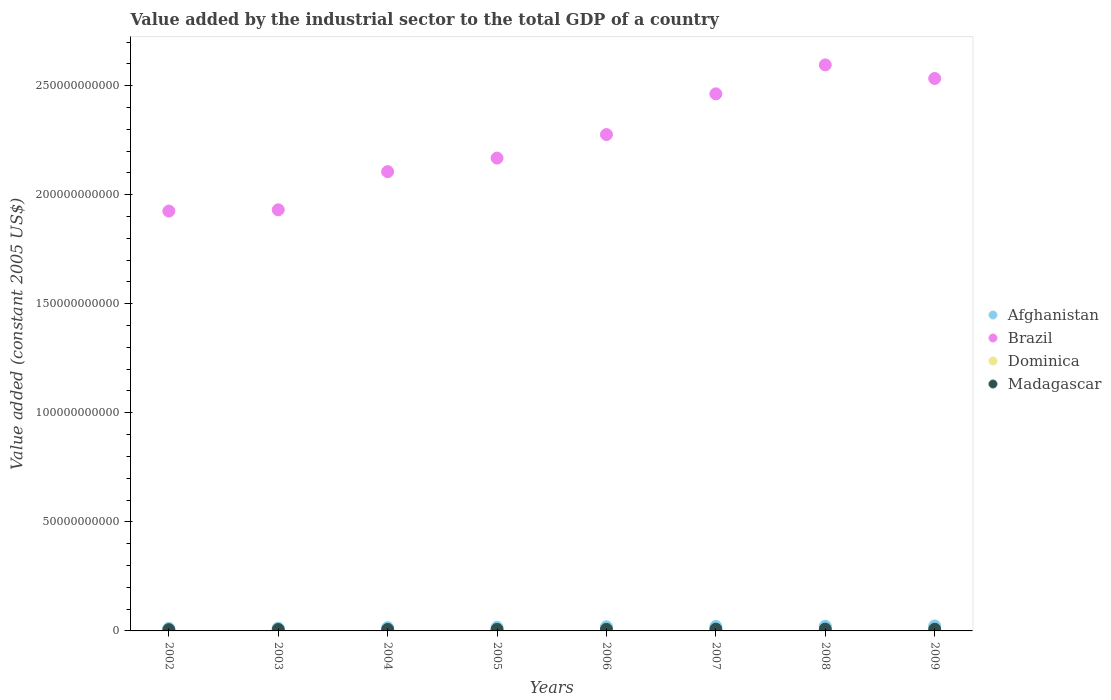What is the value added by the industrial sector in Afghanistan in 2006?
Give a very brief answer. 1.89e+09. Across all years, what is the maximum value added by the industrial sector in Brazil?
Make the answer very short. 2.60e+11. Across all years, what is the minimum value added by the industrial sector in Madagascar?
Offer a very short reply. 5.74e+08. What is the total value added by the industrial sector in Afghanistan in the graph?
Make the answer very short. 1.39e+1. What is the difference between the value added by the industrial sector in Afghanistan in 2005 and that in 2006?
Offer a terse response. -2.28e+08. What is the difference between the value added by the industrial sector in Madagascar in 2003 and the value added by the industrial sector in Afghanistan in 2005?
Make the answer very short. -1.01e+09. What is the average value added by the industrial sector in Brazil per year?
Your answer should be very brief. 2.25e+11. In the year 2006, what is the difference between the value added by the industrial sector in Dominica and value added by the industrial sector in Afghanistan?
Make the answer very short. -1.84e+09. What is the ratio of the value added by the industrial sector in Afghanistan in 2003 to that in 2006?
Provide a short and direct response. 0.66. What is the difference between the highest and the second highest value added by the industrial sector in Afghanistan?
Make the answer very short. 1.32e+08. What is the difference between the highest and the lowest value added by the industrial sector in Dominica?
Your answer should be very brief. 2.07e+07. In how many years, is the value added by the industrial sector in Madagascar greater than the average value added by the industrial sector in Madagascar taken over all years?
Ensure brevity in your answer.  4. Is the sum of the value added by the industrial sector in Afghanistan in 2002 and 2003 greater than the maximum value added by the industrial sector in Brazil across all years?
Give a very brief answer. No. Is it the case that in every year, the sum of the value added by the industrial sector in Brazil and value added by the industrial sector in Afghanistan  is greater than the sum of value added by the industrial sector in Madagascar and value added by the industrial sector in Dominica?
Provide a short and direct response. Yes. Is the value added by the industrial sector in Dominica strictly greater than the value added by the industrial sector in Afghanistan over the years?
Provide a succinct answer. No. Is the value added by the industrial sector in Afghanistan strictly less than the value added by the industrial sector in Dominica over the years?
Make the answer very short. No. How many dotlines are there?
Offer a terse response. 4. How many years are there in the graph?
Provide a short and direct response. 8. What is the difference between two consecutive major ticks on the Y-axis?
Make the answer very short. 5.00e+1. Are the values on the major ticks of Y-axis written in scientific E-notation?
Offer a terse response. No. Does the graph contain any zero values?
Your response must be concise. No. How are the legend labels stacked?
Your response must be concise. Vertical. What is the title of the graph?
Offer a very short reply. Value added by the industrial sector to the total GDP of a country. What is the label or title of the Y-axis?
Your answer should be very brief. Value added (constant 2005 US$). What is the Value added (constant 2005 US$) in Afghanistan in 2002?
Offer a terse response. 1.14e+09. What is the Value added (constant 2005 US$) in Brazil in 2002?
Your answer should be compact. 1.92e+11. What is the Value added (constant 2005 US$) of Dominica in 2002?
Offer a very short reply. 3.76e+07. What is the Value added (constant 2005 US$) of Madagascar in 2002?
Your answer should be very brief. 5.74e+08. What is the Value added (constant 2005 US$) of Afghanistan in 2003?
Keep it short and to the point. 1.25e+09. What is the Value added (constant 2005 US$) in Brazil in 2003?
Provide a succinct answer. 1.93e+11. What is the Value added (constant 2005 US$) of Dominica in 2003?
Offer a terse response. 4.21e+07. What is the Value added (constant 2005 US$) in Madagascar in 2003?
Provide a succinct answer. 6.58e+08. What is the Value added (constant 2005 US$) of Afghanistan in 2004?
Your response must be concise. 1.47e+09. What is the Value added (constant 2005 US$) in Brazil in 2004?
Keep it short and to the point. 2.11e+11. What is the Value added (constant 2005 US$) of Dominica in 2004?
Your answer should be compact. 4.60e+07. What is the Value added (constant 2005 US$) of Madagascar in 2004?
Keep it short and to the point. 7.01e+08. What is the Value added (constant 2005 US$) of Afghanistan in 2005?
Ensure brevity in your answer.  1.66e+09. What is the Value added (constant 2005 US$) of Brazil in 2005?
Give a very brief answer. 2.17e+11. What is the Value added (constant 2005 US$) of Dominica in 2005?
Keep it short and to the point. 4.74e+07. What is the Value added (constant 2005 US$) of Madagascar in 2005?
Provide a succinct answer. 7.21e+08. What is the Value added (constant 2005 US$) in Afghanistan in 2006?
Provide a succinct answer. 1.89e+09. What is the Value added (constant 2005 US$) of Brazil in 2006?
Offer a very short reply. 2.28e+11. What is the Value added (constant 2005 US$) in Dominica in 2006?
Give a very brief answer. 4.98e+07. What is the Value added (constant 2005 US$) in Madagascar in 2006?
Make the answer very short. 7.47e+08. What is the Value added (constant 2005 US$) in Afghanistan in 2007?
Provide a short and direct response. 2.04e+09. What is the Value added (constant 2005 US$) in Brazil in 2007?
Provide a succinct answer. 2.46e+11. What is the Value added (constant 2005 US$) of Dominica in 2007?
Offer a very short reply. 5.39e+07. What is the Value added (constant 2005 US$) of Madagascar in 2007?
Provide a short and direct response. 8.20e+08. What is the Value added (constant 2005 US$) of Afghanistan in 2008?
Your response must be concise. 2.15e+09. What is the Value added (constant 2005 US$) in Brazil in 2008?
Your answer should be compact. 2.60e+11. What is the Value added (constant 2005 US$) of Dominica in 2008?
Your answer should be very brief. 5.82e+07. What is the Value added (constant 2005 US$) in Madagascar in 2008?
Make the answer very short. 8.50e+08. What is the Value added (constant 2005 US$) in Afghanistan in 2009?
Give a very brief answer. 2.29e+09. What is the Value added (constant 2005 US$) in Brazil in 2009?
Make the answer very short. 2.53e+11. What is the Value added (constant 2005 US$) of Dominica in 2009?
Ensure brevity in your answer.  5.35e+07. What is the Value added (constant 2005 US$) in Madagascar in 2009?
Your answer should be very brief. 7.83e+08. Across all years, what is the maximum Value added (constant 2005 US$) of Afghanistan?
Give a very brief answer. 2.29e+09. Across all years, what is the maximum Value added (constant 2005 US$) in Brazil?
Your response must be concise. 2.60e+11. Across all years, what is the maximum Value added (constant 2005 US$) of Dominica?
Your answer should be compact. 5.82e+07. Across all years, what is the maximum Value added (constant 2005 US$) of Madagascar?
Ensure brevity in your answer.  8.50e+08. Across all years, what is the minimum Value added (constant 2005 US$) of Afghanistan?
Offer a very short reply. 1.14e+09. Across all years, what is the minimum Value added (constant 2005 US$) of Brazil?
Give a very brief answer. 1.92e+11. Across all years, what is the minimum Value added (constant 2005 US$) of Dominica?
Provide a short and direct response. 3.76e+07. Across all years, what is the minimum Value added (constant 2005 US$) of Madagascar?
Ensure brevity in your answer.  5.74e+08. What is the total Value added (constant 2005 US$) of Afghanistan in the graph?
Your answer should be compact. 1.39e+1. What is the total Value added (constant 2005 US$) in Brazil in the graph?
Offer a very short reply. 1.80e+12. What is the total Value added (constant 2005 US$) in Dominica in the graph?
Make the answer very short. 3.89e+08. What is the total Value added (constant 2005 US$) in Madagascar in the graph?
Give a very brief answer. 5.85e+09. What is the difference between the Value added (constant 2005 US$) of Afghanistan in 2002 and that in 2003?
Ensure brevity in your answer.  -1.17e+08. What is the difference between the Value added (constant 2005 US$) in Brazil in 2002 and that in 2003?
Your answer should be very brief. -5.84e+08. What is the difference between the Value added (constant 2005 US$) of Dominica in 2002 and that in 2003?
Provide a succinct answer. -4.49e+06. What is the difference between the Value added (constant 2005 US$) of Madagascar in 2002 and that in 2003?
Offer a terse response. -8.32e+07. What is the difference between the Value added (constant 2005 US$) in Afghanistan in 2002 and that in 2004?
Give a very brief answer. -3.36e+08. What is the difference between the Value added (constant 2005 US$) in Brazil in 2002 and that in 2004?
Offer a very short reply. -1.81e+1. What is the difference between the Value added (constant 2005 US$) of Dominica in 2002 and that in 2004?
Provide a short and direct response. -8.46e+06. What is the difference between the Value added (constant 2005 US$) of Madagascar in 2002 and that in 2004?
Keep it short and to the point. -1.26e+08. What is the difference between the Value added (constant 2005 US$) in Afghanistan in 2002 and that in 2005?
Keep it short and to the point. -5.27e+08. What is the difference between the Value added (constant 2005 US$) in Brazil in 2002 and that in 2005?
Make the answer very short. -2.43e+1. What is the difference between the Value added (constant 2005 US$) in Dominica in 2002 and that in 2005?
Provide a succinct answer. -9.82e+06. What is the difference between the Value added (constant 2005 US$) in Madagascar in 2002 and that in 2005?
Offer a terse response. -1.47e+08. What is the difference between the Value added (constant 2005 US$) of Afghanistan in 2002 and that in 2006?
Offer a very short reply. -7.55e+08. What is the difference between the Value added (constant 2005 US$) of Brazil in 2002 and that in 2006?
Offer a very short reply. -3.51e+1. What is the difference between the Value added (constant 2005 US$) of Dominica in 2002 and that in 2006?
Offer a terse response. -1.22e+07. What is the difference between the Value added (constant 2005 US$) of Madagascar in 2002 and that in 2006?
Offer a very short reply. -1.73e+08. What is the difference between the Value added (constant 2005 US$) in Afghanistan in 2002 and that in 2007?
Make the answer very short. -8.99e+08. What is the difference between the Value added (constant 2005 US$) of Brazil in 2002 and that in 2007?
Make the answer very short. -5.37e+1. What is the difference between the Value added (constant 2005 US$) in Dominica in 2002 and that in 2007?
Make the answer very short. -1.63e+07. What is the difference between the Value added (constant 2005 US$) of Madagascar in 2002 and that in 2007?
Ensure brevity in your answer.  -2.46e+08. What is the difference between the Value added (constant 2005 US$) in Afghanistan in 2002 and that in 2008?
Offer a very short reply. -1.02e+09. What is the difference between the Value added (constant 2005 US$) of Brazil in 2002 and that in 2008?
Offer a terse response. -6.70e+1. What is the difference between the Value added (constant 2005 US$) in Dominica in 2002 and that in 2008?
Your answer should be compact. -2.07e+07. What is the difference between the Value added (constant 2005 US$) in Madagascar in 2002 and that in 2008?
Your answer should be compact. -2.75e+08. What is the difference between the Value added (constant 2005 US$) in Afghanistan in 2002 and that in 2009?
Provide a short and direct response. -1.15e+09. What is the difference between the Value added (constant 2005 US$) in Brazil in 2002 and that in 2009?
Provide a succinct answer. -6.08e+1. What is the difference between the Value added (constant 2005 US$) in Dominica in 2002 and that in 2009?
Your response must be concise. -1.59e+07. What is the difference between the Value added (constant 2005 US$) in Madagascar in 2002 and that in 2009?
Your answer should be very brief. -2.09e+08. What is the difference between the Value added (constant 2005 US$) in Afghanistan in 2003 and that in 2004?
Offer a terse response. -2.19e+08. What is the difference between the Value added (constant 2005 US$) in Brazil in 2003 and that in 2004?
Ensure brevity in your answer.  -1.75e+1. What is the difference between the Value added (constant 2005 US$) in Dominica in 2003 and that in 2004?
Offer a very short reply. -3.97e+06. What is the difference between the Value added (constant 2005 US$) in Madagascar in 2003 and that in 2004?
Ensure brevity in your answer.  -4.31e+07. What is the difference between the Value added (constant 2005 US$) of Afghanistan in 2003 and that in 2005?
Provide a short and direct response. -4.11e+08. What is the difference between the Value added (constant 2005 US$) in Brazil in 2003 and that in 2005?
Ensure brevity in your answer.  -2.37e+1. What is the difference between the Value added (constant 2005 US$) of Dominica in 2003 and that in 2005?
Make the answer very short. -5.34e+06. What is the difference between the Value added (constant 2005 US$) in Madagascar in 2003 and that in 2005?
Your response must be concise. -6.38e+07. What is the difference between the Value added (constant 2005 US$) of Afghanistan in 2003 and that in 2006?
Provide a succinct answer. -6.38e+08. What is the difference between the Value added (constant 2005 US$) of Brazil in 2003 and that in 2006?
Your answer should be compact. -3.45e+1. What is the difference between the Value added (constant 2005 US$) in Dominica in 2003 and that in 2006?
Make the answer very short. -7.73e+06. What is the difference between the Value added (constant 2005 US$) in Madagascar in 2003 and that in 2006?
Your response must be concise. -8.93e+07. What is the difference between the Value added (constant 2005 US$) of Afghanistan in 2003 and that in 2007?
Your answer should be compact. -7.83e+08. What is the difference between the Value added (constant 2005 US$) in Brazil in 2003 and that in 2007?
Give a very brief answer. -5.32e+1. What is the difference between the Value added (constant 2005 US$) in Dominica in 2003 and that in 2007?
Your answer should be very brief. -1.18e+07. What is the difference between the Value added (constant 2005 US$) of Madagascar in 2003 and that in 2007?
Provide a succinct answer. -1.63e+08. What is the difference between the Value added (constant 2005 US$) of Afghanistan in 2003 and that in 2008?
Give a very brief answer. -8.99e+08. What is the difference between the Value added (constant 2005 US$) in Brazil in 2003 and that in 2008?
Your response must be concise. -6.64e+1. What is the difference between the Value added (constant 2005 US$) of Dominica in 2003 and that in 2008?
Provide a succinct answer. -1.62e+07. What is the difference between the Value added (constant 2005 US$) of Madagascar in 2003 and that in 2008?
Provide a succinct answer. -1.92e+08. What is the difference between the Value added (constant 2005 US$) of Afghanistan in 2003 and that in 2009?
Provide a succinct answer. -1.03e+09. What is the difference between the Value added (constant 2005 US$) of Brazil in 2003 and that in 2009?
Provide a succinct answer. -6.02e+1. What is the difference between the Value added (constant 2005 US$) in Dominica in 2003 and that in 2009?
Offer a terse response. -1.15e+07. What is the difference between the Value added (constant 2005 US$) in Madagascar in 2003 and that in 2009?
Your response must be concise. -1.26e+08. What is the difference between the Value added (constant 2005 US$) of Afghanistan in 2004 and that in 2005?
Ensure brevity in your answer.  -1.91e+08. What is the difference between the Value added (constant 2005 US$) in Brazil in 2004 and that in 2005?
Your answer should be compact. -6.22e+09. What is the difference between the Value added (constant 2005 US$) in Dominica in 2004 and that in 2005?
Your answer should be very brief. -1.36e+06. What is the difference between the Value added (constant 2005 US$) in Madagascar in 2004 and that in 2005?
Your answer should be compact. -2.08e+07. What is the difference between the Value added (constant 2005 US$) in Afghanistan in 2004 and that in 2006?
Your answer should be compact. -4.19e+08. What is the difference between the Value added (constant 2005 US$) of Brazil in 2004 and that in 2006?
Your response must be concise. -1.70e+1. What is the difference between the Value added (constant 2005 US$) in Dominica in 2004 and that in 2006?
Offer a very short reply. -3.76e+06. What is the difference between the Value added (constant 2005 US$) of Madagascar in 2004 and that in 2006?
Provide a short and direct response. -4.63e+07. What is the difference between the Value added (constant 2005 US$) in Afghanistan in 2004 and that in 2007?
Your answer should be very brief. -5.63e+08. What is the difference between the Value added (constant 2005 US$) of Brazil in 2004 and that in 2007?
Offer a very short reply. -3.57e+1. What is the difference between the Value added (constant 2005 US$) in Dominica in 2004 and that in 2007?
Your answer should be very brief. -7.86e+06. What is the difference between the Value added (constant 2005 US$) of Madagascar in 2004 and that in 2007?
Your answer should be very brief. -1.20e+08. What is the difference between the Value added (constant 2005 US$) of Afghanistan in 2004 and that in 2008?
Offer a very short reply. -6.80e+08. What is the difference between the Value added (constant 2005 US$) of Brazil in 2004 and that in 2008?
Your answer should be very brief. -4.90e+1. What is the difference between the Value added (constant 2005 US$) in Dominica in 2004 and that in 2008?
Ensure brevity in your answer.  -1.22e+07. What is the difference between the Value added (constant 2005 US$) of Madagascar in 2004 and that in 2008?
Give a very brief answer. -1.49e+08. What is the difference between the Value added (constant 2005 US$) of Afghanistan in 2004 and that in 2009?
Your answer should be compact. -8.12e+08. What is the difference between the Value added (constant 2005 US$) in Brazil in 2004 and that in 2009?
Make the answer very short. -4.27e+1. What is the difference between the Value added (constant 2005 US$) of Dominica in 2004 and that in 2009?
Ensure brevity in your answer.  -7.49e+06. What is the difference between the Value added (constant 2005 US$) of Madagascar in 2004 and that in 2009?
Provide a succinct answer. -8.26e+07. What is the difference between the Value added (constant 2005 US$) of Afghanistan in 2005 and that in 2006?
Ensure brevity in your answer.  -2.28e+08. What is the difference between the Value added (constant 2005 US$) in Brazil in 2005 and that in 2006?
Provide a short and direct response. -1.08e+1. What is the difference between the Value added (constant 2005 US$) in Dominica in 2005 and that in 2006?
Make the answer very short. -2.40e+06. What is the difference between the Value added (constant 2005 US$) of Madagascar in 2005 and that in 2006?
Make the answer very short. -2.55e+07. What is the difference between the Value added (constant 2005 US$) of Afghanistan in 2005 and that in 2007?
Make the answer very short. -3.72e+08. What is the difference between the Value added (constant 2005 US$) in Brazil in 2005 and that in 2007?
Your answer should be very brief. -2.95e+1. What is the difference between the Value added (constant 2005 US$) in Dominica in 2005 and that in 2007?
Provide a succinct answer. -6.49e+06. What is the difference between the Value added (constant 2005 US$) in Madagascar in 2005 and that in 2007?
Keep it short and to the point. -9.88e+07. What is the difference between the Value added (constant 2005 US$) of Afghanistan in 2005 and that in 2008?
Provide a short and direct response. -4.89e+08. What is the difference between the Value added (constant 2005 US$) in Brazil in 2005 and that in 2008?
Provide a short and direct response. -4.27e+1. What is the difference between the Value added (constant 2005 US$) in Dominica in 2005 and that in 2008?
Provide a succinct answer. -1.08e+07. What is the difference between the Value added (constant 2005 US$) in Madagascar in 2005 and that in 2008?
Give a very brief answer. -1.28e+08. What is the difference between the Value added (constant 2005 US$) in Afghanistan in 2005 and that in 2009?
Keep it short and to the point. -6.20e+08. What is the difference between the Value added (constant 2005 US$) in Brazil in 2005 and that in 2009?
Provide a short and direct response. -3.65e+1. What is the difference between the Value added (constant 2005 US$) of Dominica in 2005 and that in 2009?
Keep it short and to the point. -6.12e+06. What is the difference between the Value added (constant 2005 US$) in Madagascar in 2005 and that in 2009?
Offer a terse response. -6.19e+07. What is the difference between the Value added (constant 2005 US$) in Afghanistan in 2006 and that in 2007?
Offer a terse response. -1.44e+08. What is the difference between the Value added (constant 2005 US$) in Brazil in 2006 and that in 2007?
Ensure brevity in your answer.  -1.87e+1. What is the difference between the Value added (constant 2005 US$) in Dominica in 2006 and that in 2007?
Your answer should be very brief. -4.09e+06. What is the difference between the Value added (constant 2005 US$) in Madagascar in 2006 and that in 2007?
Keep it short and to the point. -7.33e+07. What is the difference between the Value added (constant 2005 US$) in Afghanistan in 2006 and that in 2008?
Offer a very short reply. -2.61e+08. What is the difference between the Value added (constant 2005 US$) in Brazil in 2006 and that in 2008?
Offer a terse response. -3.19e+1. What is the difference between the Value added (constant 2005 US$) in Dominica in 2006 and that in 2008?
Ensure brevity in your answer.  -8.44e+06. What is the difference between the Value added (constant 2005 US$) in Madagascar in 2006 and that in 2008?
Give a very brief answer. -1.03e+08. What is the difference between the Value added (constant 2005 US$) of Afghanistan in 2006 and that in 2009?
Your answer should be very brief. -3.93e+08. What is the difference between the Value added (constant 2005 US$) in Brazil in 2006 and that in 2009?
Provide a short and direct response. -2.57e+1. What is the difference between the Value added (constant 2005 US$) of Dominica in 2006 and that in 2009?
Your answer should be compact. -3.72e+06. What is the difference between the Value added (constant 2005 US$) of Madagascar in 2006 and that in 2009?
Provide a succinct answer. -3.64e+07. What is the difference between the Value added (constant 2005 US$) of Afghanistan in 2007 and that in 2008?
Offer a terse response. -1.17e+08. What is the difference between the Value added (constant 2005 US$) of Brazil in 2007 and that in 2008?
Provide a short and direct response. -1.33e+1. What is the difference between the Value added (constant 2005 US$) of Dominica in 2007 and that in 2008?
Your answer should be compact. -4.34e+06. What is the difference between the Value added (constant 2005 US$) of Madagascar in 2007 and that in 2008?
Your answer should be very brief. -2.93e+07. What is the difference between the Value added (constant 2005 US$) in Afghanistan in 2007 and that in 2009?
Your answer should be very brief. -2.48e+08. What is the difference between the Value added (constant 2005 US$) in Brazil in 2007 and that in 2009?
Provide a short and direct response. -7.04e+09. What is the difference between the Value added (constant 2005 US$) of Dominica in 2007 and that in 2009?
Your answer should be very brief. 3.71e+05. What is the difference between the Value added (constant 2005 US$) in Madagascar in 2007 and that in 2009?
Give a very brief answer. 3.70e+07. What is the difference between the Value added (constant 2005 US$) in Afghanistan in 2008 and that in 2009?
Make the answer very short. -1.32e+08. What is the difference between the Value added (constant 2005 US$) in Brazil in 2008 and that in 2009?
Offer a terse response. 6.24e+09. What is the difference between the Value added (constant 2005 US$) in Dominica in 2008 and that in 2009?
Provide a short and direct response. 4.72e+06. What is the difference between the Value added (constant 2005 US$) in Madagascar in 2008 and that in 2009?
Offer a terse response. 6.63e+07. What is the difference between the Value added (constant 2005 US$) of Afghanistan in 2002 and the Value added (constant 2005 US$) of Brazil in 2003?
Your answer should be very brief. -1.92e+11. What is the difference between the Value added (constant 2005 US$) of Afghanistan in 2002 and the Value added (constant 2005 US$) of Dominica in 2003?
Ensure brevity in your answer.  1.10e+09. What is the difference between the Value added (constant 2005 US$) in Afghanistan in 2002 and the Value added (constant 2005 US$) in Madagascar in 2003?
Provide a short and direct response. 4.80e+08. What is the difference between the Value added (constant 2005 US$) in Brazil in 2002 and the Value added (constant 2005 US$) in Dominica in 2003?
Your answer should be compact. 1.92e+11. What is the difference between the Value added (constant 2005 US$) in Brazil in 2002 and the Value added (constant 2005 US$) in Madagascar in 2003?
Provide a succinct answer. 1.92e+11. What is the difference between the Value added (constant 2005 US$) in Dominica in 2002 and the Value added (constant 2005 US$) in Madagascar in 2003?
Offer a terse response. -6.20e+08. What is the difference between the Value added (constant 2005 US$) in Afghanistan in 2002 and the Value added (constant 2005 US$) in Brazil in 2004?
Offer a very short reply. -2.09e+11. What is the difference between the Value added (constant 2005 US$) of Afghanistan in 2002 and the Value added (constant 2005 US$) of Dominica in 2004?
Give a very brief answer. 1.09e+09. What is the difference between the Value added (constant 2005 US$) in Afghanistan in 2002 and the Value added (constant 2005 US$) in Madagascar in 2004?
Your answer should be very brief. 4.37e+08. What is the difference between the Value added (constant 2005 US$) of Brazil in 2002 and the Value added (constant 2005 US$) of Dominica in 2004?
Your response must be concise. 1.92e+11. What is the difference between the Value added (constant 2005 US$) in Brazil in 2002 and the Value added (constant 2005 US$) in Madagascar in 2004?
Ensure brevity in your answer.  1.92e+11. What is the difference between the Value added (constant 2005 US$) of Dominica in 2002 and the Value added (constant 2005 US$) of Madagascar in 2004?
Keep it short and to the point. -6.63e+08. What is the difference between the Value added (constant 2005 US$) of Afghanistan in 2002 and the Value added (constant 2005 US$) of Brazil in 2005?
Offer a very short reply. -2.16e+11. What is the difference between the Value added (constant 2005 US$) in Afghanistan in 2002 and the Value added (constant 2005 US$) in Dominica in 2005?
Your answer should be compact. 1.09e+09. What is the difference between the Value added (constant 2005 US$) in Afghanistan in 2002 and the Value added (constant 2005 US$) in Madagascar in 2005?
Your response must be concise. 4.16e+08. What is the difference between the Value added (constant 2005 US$) of Brazil in 2002 and the Value added (constant 2005 US$) of Dominica in 2005?
Your response must be concise. 1.92e+11. What is the difference between the Value added (constant 2005 US$) in Brazil in 2002 and the Value added (constant 2005 US$) in Madagascar in 2005?
Ensure brevity in your answer.  1.92e+11. What is the difference between the Value added (constant 2005 US$) of Dominica in 2002 and the Value added (constant 2005 US$) of Madagascar in 2005?
Give a very brief answer. -6.84e+08. What is the difference between the Value added (constant 2005 US$) of Afghanistan in 2002 and the Value added (constant 2005 US$) of Brazil in 2006?
Provide a short and direct response. -2.26e+11. What is the difference between the Value added (constant 2005 US$) in Afghanistan in 2002 and the Value added (constant 2005 US$) in Dominica in 2006?
Ensure brevity in your answer.  1.09e+09. What is the difference between the Value added (constant 2005 US$) of Afghanistan in 2002 and the Value added (constant 2005 US$) of Madagascar in 2006?
Your answer should be very brief. 3.90e+08. What is the difference between the Value added (constant 2005 US$) of Brazil in 2002 and the Value added (constant 2005 US$) of Dominica in 2006?
Offer a very short reply. 1.92e+11. What is the difference between the Value added (constant 2005 US$) in Brazil in 2002 and the Value added (constant 2005 US$) in Madagascar in 2006?
Provide a succinct answer. 1.92e+11. What is the difference between the Value added (constant 2005 US$) of Dominica in 2002 and the Value added (constant 2005 US$) of Madagascar in 2006?
Provide a short and direct response. -7.09e+08. What is the difference between the Value added (constant 2005 US$) of Afghanistan in 2002 and the Value added (constant 2005 US$) of Brazil in 2007?
Your answer should be very brief. -2.45e+11. What is the difference between the Value added (constant 2005 US$) in Afghanistan in 2002 and the Value added (constant 2005 US$) in Dominica in 2007?
Provide a short and direct response. 1.08e+09. What is the difference between the Value added (constant 2005 US$) of Afghanistan in 2002 and the Value added (constant 2005 US$) of Madagascar in 2007?
Keep it short and to the point. 3.17e+08. What is the difference between the Value added (constant 2005 US$) in Brazil in 2002 and the Value added (constant 2005 US$) in Dominica in 2007?
Your response must be concise. 1.92e+11. What is the difference between the Value added (constant 2005 US$) of Brazil in 2002 and the Value added (constant 2005 US$) of Madagascar in 2007?
Provide a short and direct response. 1.92e+11. What is the difference between the Value added (constant 2005 US$) of Dominica in 2002 and the Value added (constant 2005 US$) of Madagascar in 2007?
Provide a succinct answer. -7.83e+08. What is the difference between the Value added (constant 2005 US$) of Afghanistan in 2002 and the Value added (constant 2005 US$) of Brazil in 2008?
Provide a short and direct response. -2.58e+11. What is the difference between the Value added (constant 2005 US$) of Afghanistan in 2002 and the Value added (constant 2005 US$) of Dominica in 2008?
Provide a short and direct response. 1.08e+09. What is the difference between the Value added (constant 2005 US$) in Afghanistan in 2002 and the Value added (constant 2005 US$) in Madagascar in 2008?
Offer a terse response. 2.88e+08. What is the difference between the Value added (constant 2005 US$) in Brazil in 2002 and the Value added (constant 2005 US$) in Dominica in 2008?
Ensure brevity in your answer.  1.92e+11. What is the difference between the Value added (constant 2005 US$) of Brazil in 2002 and the Value added (constant 2005 US$) of Madagascar in 2008?
Give a very brief answer. 1.92e+11. What is the difference between the Value added (constant 2005 US$) in Dominica in 2002 and the Value added (constant 2005 US$) in Madagascar in 2008?
Give a very brief answer. -8.12e+08. What is the difference between the Value added (constant 2005 US$) in Afghanistan in 2002 and the Value added (constant 2005 US$) in Brazil in 2009?
Provide a succinct answer. -2.52e+11. What is the difference between the Value added (constant 2005 US$) of Afghanistan in 2002 and the Value added (constant 2005 US$) of Dominica in 2009?
Provide a short and direct response. 1.08e+09. What is the difference between the Value added (constant 2005 US$) in Afghanistan in 2002 and the Value added (constant 2005 US$) in Madagascar in 2009?
Your answer should be compact. 3.54e+08. What is the difference between the Value added (constant 2005 US$) in Brazil in 2002 and the Value added (constant 2005 US$) in Dominica in 2009?
Keep it short and to the point. 1.92e+11. What is the difference between the Value added (constant 2005 US$) in Brazil in 2002 and the Value added (constant 2005 US$) in Madagascar in 2009?
Your answer should be compact. 1.92e+11. What is the difference between the Value added (constant 2005 US$) of Dominica in 2002 and the Value added (constant 2005 US$) of Madagascar in 2009?
Provide a short and direct response. -7.46e+08. What is the difference between the Value added (constant 2005 US$) in Afghanistan in 2003 and the Value added (constant 2005 US$) in Brazil in 2004?
Your answer should be compact. -2.09e+11. What is the difference between the Value added (constant 2005 US$) in Afghanistan in 2003 and the Value added (constant 2005 US$) in Dominica in 2004?
Your response must be concise. 1.21e+09. What is the difference between the Value added (constant 2005 US$) of Afghanistan in 2003 and the Value added (constant 2005 US$) of Madagascar in 2004?
Make the answer very short. 5.54e+08. What is the difference between the Value added (constant 2005 US$) of Brazil in 2003 and the Value added (constant 2005 US$) of Dominica in 2004?
Provide a succinct answer. 1.93e+11. What is the difference between the Value added (constant 2005 US$) of Brazil in 2003 and the Value added (constant 2005 US$) of Madagascar in 2004?
Your response must be concise. 1.92e+11. What is the difference between the Value added (constant 2005 US$) of Dominica in 2003 and the Value added (constant 2005 US$) of Madagascar in 2004?
Offer a very short reply. -6.59e+08. What is the difference between the Value added (constant 2005 US$) of Afghanistan in 2003 and the Value added (constant 2005 US$) of Brazil in 2005?
Keep it short and to the point. -2.16e+11. What is the difference between the Value added (constant 2005 US$) of Afghanistan in 2003 and the Value added (constant 2005 US$) of Dominica in 2005?
Provide a succinct answer. 1.21e+09. What is the difference between the Value added (constant 2005 US$) of Afghanistan in 2003 and the Value added (constant 2005 US$) of Madagascar in 2005?
Give a very brief answer. 5.33e+08. What is the difference between the Value added (constant 2005 US$) of Brazil in 2003 and the Value added (constant 2005 US$) of Dominica in 2005?
Offer a terse response. 1.93e+11. What is the difference between the Value added (constant 2005 US$) of Brazil in 2003 and the Value added (constant 2005 US$) of Madagascar in 2005?
Give a very brief answer. 1.92e+11. What is the difference between the Value added (constant 2005 US$) of Dominica in 2003 and the Value added (constant 2005 US$) of Madagascar in 2005?
Your answer should be very brief. -6.79e+08. What is the difference between the Value added (constant 2005 US$) in Afghanistan in 2003 and the Value added (constant 2005 US$) in Brazil in 2006?
Your answer should be very brief. -2.26e+11. What is the difference between the Value added (constant 2005 US$) in Afghanistan in 2003 and the Value added (constant 2005 US$) in Dominica in 2006?
Ensure brevity in your answer.  1.20e+09. What is the difference between the Value added (constant 2005 US$) of Afghanistan in 2003 and the Value added (constant 2005 US$) of Madagascar in 2006?
Your answer should be compact. 5.07e+08. What is the difference between the Value added (constant 2005 US$) of Brazil in 2003 and the Value added (constant 2005 US$) of Dominica in 2006?
Provide a succinct answer. 1.93e+11. What is the difference between the Value added (constant 2005 US$) of Brazil in 2003 and the Value added (constant 2005 US$) of Madagascar in 2006?
Your response must be concise. 1.92e+11. What is the difference between the Value added (constant 2005 US$) of Dominica in 2003 and the Value added (constant 2005 US$) of Madagascar in 2006?
Make the answer very short. -7.05e+08. What is the difference between the Value added (constant 2005 US$) in Afghanistan in 2003 and the Value added (constant 2005 US$) in Brazil in 2007?
Give a very brief answer. -2.45e+11. What is the difference between the Value added (constant 2005 US$) in Afghanistan in 2003 and the Value added (constant 2005 US$) in Dominica in 2007?
Provide a short and direct response. 1.20e+09. What is the difference between the Value added (constant 2005 US$) of Afghanistan in 2003 and the Value added (constant 2005 US$) of Madagascar in 2007?
Provide a short and direct response. 4.34e+08. What is the difference between the Value added (constant 2005 US$) of Brazil in 2003 and the Value added (constant 2005 US$) of Dominica in 2007?
Provide a short and direct response. 1.93e+11. What is the difference between the Value added (constant 2005 US$) of Brazil in 2003 and the Value added (constant 2005 US$) of Madagascar in 2007?
Your response must be concise. 1.92e+11. What is the difference between the Value added (constant 2005 US$) in Dominica in 2003 and the Value added (constant 2005 US$) in Madagascar in 2007?
Offer a terse response. -7.78e+08. What is the difference between the Value added (constant 2005 US$) in Afghanistan in 2003 and the Value added (constant 2005 US$) in Brazil in 2008?
Provide a short and direct response. -2.58e+11. What is the difference between the Value added (constant 2005 US$) of Afghanistan in 2003 and the Value added (constant 2005 US$) of Dominica in 2008?
Keep it short and to the point. 1.20e+09. What is the difference between the Value added (constant 2005 US$) in Afghanistan in 2003 and the Value added (constant 2005 US$) in Madagascar in 2008?
Your answer should be very brief. 4.05e+08. What is the difference between the Value added (constant 2005 US$) of Brazil in 2003 and the Value added (constant 2005 US$) of Dominica in 2008?
Offer a terse response. 1.93e+11. What is the difference between the Value added (constant 2005 US$) in Brazil in 2003 and the Value added (constant 2005 US$) in Madagascar in 2008?
Provide a succinct answer. 1.92e+11. What is the difference between the Value added (constant 2005 US$) in Dominica in 2003 and the Value added (constant 2005 US$) in Madagascar in 2008?
Offer a very short reply. -8.07e+08. What is the difference between the Value added (constant 2005 US$) of Afghanistan in 2003 and the Value added (constant 2005 US$) of Brazil in 2009?
Make the answer very short. -2.52e+11. What is the difference between the Value added (constant 2005 US$) of Afghanistan in 2003 and the Value added (constant 2005 US$) of Dominica in 2009?
Give a very brief answer. 1.20e+09. What is the difference between the Value added (constant 2005 US$) of Afghanistan in 2003 and the Value added (constant 2005 US$) of Madagascar in 2009?
Give a very brief answer. 4.71e+08. What is the difference between the Value added (constant 2005 US$) in Brazil in 2003 and the Value added (constant 2005 US$) in Dominica in 2009?
Provide a succinct answer. 1.93e+11. What is the difference between the Value added (constant 2005 US$) of Brazil in 2003 and the Value added (constant 2005 US$) of Madagascar in 2009?
Your response must be concise. 1.92e+11. What is the difference between the Value added (constant 2005 US$) in Dominica in 2003 and the Value added (constant 2005 US$) in Madagascar in 2009?
Your response must be concise. -7.41e+08. What is the difference between the Value added (constant 2005 US$) of Afghanistan in 2004 and the Value added (constant 2005 US$) of Brazil in 2005?
Your response must be concise. -2.15e+11. What is the difference between the Value added (constant 2005 US$) of Afghanistan in 2004 and the Value added (constant 2005 US$) of Dominica in 2005?
Your response must be concise. 1.43e+09. What is the difference between the Value added (constant 2005 US$) in Afghanistan in 2004 and the Value added (constant 2005 US$) in Madagascar in 2005?
Ensure brevity in your answer.  7.52e+08. What is the difference between the Value added (constant 2005 US$) in Brazil in 2004 and the Value added (constant 2005 US$) in Dominica in 2005?
Ensure brevity in your answer.  2.11e+11. What is the difference between the Value added (constant 2005 US$) in Brazil in 2004 and the Value added (constant 2005 US$) in Madagascar in 2005?
Provide a succinct answer. 2.10e+11. What is the difference between the Value added (constant 2005 US$) in Dominica in 2004 and the Value added (constant 2005 US$) in Madagascar in 2005?
Provide a short and direct response. -6.75e+08. What is the difference between the Value added (constant 2005 US$) in Afghanistan in 2004 and the Value added (constant 2005 US$) in Brazil in 2006?
Your response must be concise. -2.26e+11. What is the difference between the Value added (constant 2005 US$) in Afghanistan in 2004 and the Value added (constant 2005 US$) in Dominica in 2006?
Your response must be concise. 1.42e+09. What is the difference between the Value added (constant 2005 US$) in Afghanistan in 2004 and the Value added (constant 2005 US$) in Madagascar in 2006?
Offer a terse response. 7.26e+08. What is the difference between the Value added (constant 2005 US$) in Brazil in 2004 and the Value added (constant 2005 US$) in Dominica in 2006?
Offer a very short reply. 2.11e+11. What is the difference between the Value added (constant 2005 US$) in Brazil in 2004 and the Value added (constant 2005 US$) in Madagascar in 2006?
Make the answer very short. 2.10e+11. What is the difference between the Value added (constant 2005 US$) in Dominica in 2004 and the Value added (constant 2005 US$) in Madagascar in 2006?
Your answer should be compact. -7.01e+08. What is the difference between the Value added (constant 2005 US$) in Afghanistan in 2004 and the Value added (constant 2005 US$) in Brazil in 2007?
Offer a terse response. -2.45e+11. What is the difference between the Value added (constant 2005 US$) in Afghanistan in 2004 and the Value added (constant 2005 US$) in Dominica in 2007?
Offer a very short reply. 1.42e+09. What is the difference between the Value added (constant 2005 US$) of Afghanistan in 2004 and the Value added (constant 2005 US$) of Madagascar in 2007?
Provide a short and direct response. 6.53e+08. What is the difference between the Value added (constant 2005 US$) of Brazil in 2004 and the Value added (constant 2005 US$) of Dominica in 2007?
Give a very brief answer. 2.11e+11. What is the difference between the Value added (constant 2005 US$) in Brazil in 2004 and the Value added (constant 2005 US$) in Madagascar in 2007?
Ensure brevity in your answer.  2.10e+11. What is the difference between the Value added (constant 2005 US$) of Dominica in 2004 and the Value added (constant 2005 US$) of Madagascar in 2007?
Your answer should be compact. -7.74e+08. What is the difference between the Value added (constant 2005 US$) in Afghanistan in 2004 and the Value added (constant 2005 US$) in Brazil in 2008?
Provide a short and direct response. -2.58e+11. What is the difference between the Value added (constant 2005 US$) of Afghanistan in 2004 and the Value added (constant 2005 US$) of Dominica in 2008?
Ensure brevity in your answer.  1.42e+09. What is the difference between the Value added (constant 2005 US$) in Afghanistan in 2004 and the Value added (constant 2005 US$) in Madagascar in 2008?
Your answer should be very brief. 6.24e+08. What is the difference between the Value added (constant 2005 US$) of Brazil in 2004 and the Value added (constant 2005 US$) of Dominica in 2008?
Offer a terse response. 2.10e+11. What is the difference between the Value added (constant 2005 US$) of Brazil in 2004 and the Value added (constant 2005 US$) of Madagascar in 2008?
Provide a short and direct response. 2.10e+11. What is the difference between the Value added (constant 2005 US$) in Dominica in 2004 and the Value added (constant 2005 US$) in Madagascar in 2008?
Your answer should be compact. -8.04e+08. What is the difference between the Value added (constant 2005 US$) in Afghanistan in 2004 and the Value added (constant 2005 US$) in Brazil in 2009?
Your response must be concise. -2.52e+11. What is the difference between the Value added (constant 2005 US$) of Afghanistan in 2004 and the Value added (constant 2005 US$) of Dominica in 2009?
Make the answer very short. 1.42e+09. What is the difference between the Value added (constant 2005 US$) of Afghanistan in 2004 and the Value added (constant 2005 US$) of Madagascar in 2009?
Offer a very short reply. 6.90e+08. What is the difference between the Value added (constant 2005 US$) of Brazil in 2004 and the Value added (constant 2005 US$) of Dominica in 2009?
Make the answer very short. 2.11e+11. What is the difference between the Value added (constant 2005 US$) of Brazil in 2004 and the Value added (constant 2005 US$) of Madagascar in 2009?
Provide a succinct answer. 2.10e+11. What is the difference between the Value added (constant 2005 US$) in Dominica in 2004 and the Value added (constant 2005 US$) in Madagascar in 2009?
Give a very brief answer. -7.37e+08. What is the difference between the Value added (constant 2005 US$) in Afghanistan in 2005 and the Value added (constant 2005 US$) in Brazil in 2006?
Offer a very short reply. -2.26e+11. What is the difference between the Value added (constant 2005 US$) of Afghanistan in 2005 and the Value added (constant 2005 US$) of Dominica in 2006?
Your answer should be very brief. 1.61e+09. What is the difference between the Value added (constant 2005 US$) in Afghanistan in 2005 and the Value added (constant 2005 US$) in Madagascar in 2006?
Your answer should be compact. 9.18e+08. What is the difference between the Value added (constant 2005 US$) of Brazil in 2005 and the Value added (constant 2005 US$) of Dominica in 2006?
Your answer should be compact. 2.17e+11. What is the difference between the Value added (constant 2005 US$) in Brazil in 2005 and the Value added (constant 2005 US$) in Madagascar in 2006?
Make the answer very short. 2.16e+11. What is the difference between the Value added (constant 2005 US$) in Dominica in 2005 and the Value added (constant 2005 US$) in Madagascar in 2006?
Offer a very short reply. -7.00e+08. What is the difference between the Value added (constant 2005 US$) of Afghanistan in 2005 and the Value added (constant 2005 US$) of Brazil in 2007?
Your answer should be very brief. -2.45e+11. What is the difference between the Value added (constant 2005 US$) in Afghanistan in 2005 and the Value added (constant 2005 US$) in Dominica in 2007?
Your answer should be compact. 1.61e+09. What is the difference between the Value added (constant 2005 US$) in Afghanistan in 2005 and the Value added (constant 2005 US$) in Madagascar in 2007?
Offer a terse response. 8.45e+08. What is the difference between the Value added (constant 2005 US$) in Brazil in 2005 and the Value added (constant 2005 US$) in Dominica in 2007?
Provide a succinct answer. 2.17e+11. What is the difference between the Value added (constant 2005 US$) in Brazil in 2005 and the Value added (constant 2005 US$) in Madagascar in 2007?
Offer a very short reply. 2.16e+11. What is the difference between the Value added (constant 2005 US$) of Dominica in 2005 and the Value added (constant 2005 US$) of Madagascar in 2007?
Your response must be concise. -7.73e+08. What is the difference between the Value added (constant 2005 US$) in Afghanistan in 2005 and the Value added (constant 2005 US$) in Brazil in 2008?
Offer a terse response. -2.58e+11. What is the difference between the Value added (constant 2005 US$) of Afghanistan in 2005 and the Value added (constant 2005 US$) of Dominica in 2008?
Your answer should be compact. 1.61e+09. What is the difference between the Value added (constant 2005 US$) of Afghanistan in 2005 and the Value added (constant 2005 US$) of Madagascar in 2008?
Give a very brief answer. 8.15e+08. What is the difference between the Value added (constant 2005 US$) of Brazil in 2005 and the Value added (constant 2005 US$) of Dominica in 2008?
Give a very brief answer. 2.17e+11. What is the difference between the Value added (constant 2005 US$) in Brazil in 2005 and the Value added (constant 2005 US$) in Madagascar in 2008?
Ensure brevity in your answer.  2.16e+11. What is the difference between the Value added (constant 2005 US$) of Dominica in 2005 and the Value added (constant 2005 US$) of Madagascar in 2008?
Your response must be concise. -8.02e+08. What is the difference between the Value added (constant 2005 US$) in Afghanistan in 2005 and the Value added (constant 2005 US$) in Brazil in 2009?
Ensure brevity in your answer.  -2.52e+11. What is the difference between the Value added (constant 2005 US$) in Afghanistan in 2005 and the Value added (constant 2005 US$) in Dominica in 2009?
Your answer should be compact. 1.61e+09. What is the difference between the Value added (constant 2005 US$) in Afghanistan in 2005 and the Value added (constant 2005 US$) in Madagascar in 2009?
Offer a terse response. 8.82e+08. What is the difference between the Value added (constant 2005 US$) of Brazil in 2005 and the Value added (constant 2005 US$) of Dominica in 2009?
Your answer should be very brief. 2.17e+11. What is the difference between the Value added (constant 2005 US$) in Brazil in 2005 and the Value added (constant 2005 US$) in Madagascar in 2009?
Your response must be concise. 2.16e+11. What is the difference between the Value added (constant 2005 US$) of Dominica in 2005 and the Value added (constant 2005 US$) of Madagascar in 2009?
Provide a short and direct response. -7.36e+08. What is the difference between the Value added (constant 2005 US$) in Afghanistan in 2006 and the Value added (constant 2005 US$) in Brazil in 2007?
Offer a very short reply. -2.44e+11. What is the difference between the Value added (constant 2005 US$) in Afghanistan in 2006 and the Value added (constant 2005 US$) in Dominica in 2007?
Give a very brief answer. 1.84e+09. What is the difference between the Value added (constant 2005 US$) of Afghanistan in 2006 and the Value added (constant 2005 US$) of Madagascar in 2007?
Ensure brevity in your answer.  1.07e+09. What is the difference between the Value added (constant 2005 US$) in Brazil in 2006 and the Value added (constant 2005 US$) in Dominica in 2007?
Provide a succinct answer. 2.28e+11. What is the difference between the Value added (constant 2005 US$) of Brazil in 2006 and the Value added (constant 2005 US$) of Madagascar in 2007?
Your answer should be very brief. 2.27e+11. What is the difference between the Value added (constant 2005 US$) of Dominica in 2006 and the Value added (constant 2005 US$) of Madagascar in 2007?
Offer a very short reply. -7.70e+08. What is the difference between the Value added (constant 2005 US$) in Afghanistan in 2006 and the Value added (constant 2005 US$) in Brazil in 2008?
Your answer should be very brief. -2.58e+11. What is the difference between the Value added (constant 2005 US$) in Afghanistan in 2006 and the Value added (constant 2005 US$) in Dominica in 2008?
Your response must be concise. 1.83e+09. What is the difference between the Value added (constant 2005 US$) of Afghanistan in 2006 and the Value added (constant 2005 US$) of Madagascar in 2008?
Provide a short and direct response. 1.04e+09. What is the difference between the Value added (constant 2005 US$) in Brazil in 2006 and the Value added (constant 2005 US$) in Dominica in 2008?
Your answer should be very brief. 2.28e+11. What is the difference between the Value added (constant 2005 US$) in Brazil in 2006 and the Value added (constant 2005 US$) in Madagascar in 2008?
Provide a succinct answer. 2.27e+11. What is the difference between the Value added (constant 2005 US$) in Dominica in 2006 and the Value added (constant 2005 US$) in Madagascar in 2008?
Your response must be concise. -8.00e+08. What is the difference between the Value added (constant 2005 US$) of Afghanistan in 2006 and the Value added (constant 2005 US$) of Brazil in 2009?
Provide a succinct answer. -2.51e+11. What is the difference between the Value added (constant 2005 US$) in Afghanistan in 2006 and the Value added (constant 2005 US$) in Dominica in 2009?
Provide a succinct answer. 1.84e+09. What is the difference between the Value added (constant 2005 US$) of Afghanistan in 2006 and the Value added (constant 2005 US$) of Madagascar in 2009?
Make the answer very short. 1.11e+09. What is the difference between the Value added (constant 2005 US$) in Brazil in 2006 and the Value added (constant 2005 US$) in Dominica in 2009?
Offer a terse response. 2.28e+11. What is the difference between the Value added (constant 2005 US$) of Brazil in 2006 and the Value added (constant 2005 US$) of Madagascar in 2009?
Your answer should be compact. 2.27e+11. What is the difference between the Value added (constant 2005 US$) of Dominica in 2006 and the Value added (constant 2005 US$) of Madagascar in 2009?
Offer a terse response. -7.33e+08. What is the difference between the Value added (constant 2005 US$) in Afghanistan in 2007 and the Value added (constant 2005 US$) in Brazil in 2008?
Ensure brevity in your answer.  -2.57e+11. What is the difference between the Value added (constant 2005 US$) of Afghanistan in 2007 and the Value added (constant 2005 US$) of Dominica in 2008?
Ensure brevity in your answer.  1.98e+09. What is the difference between the Value added (constant 2005 US$) of Afghanistan in 2007 and the Value added (constant 2005 US$) of Madagascar in 2008?
Ensure brevity in your answer.  1.19e+09. What is the difference between the Value added (constant 2005 US$) of Brazil in 2007 and the Value added (constant 2005 US$) of Dominica in 2008?
Ensure brevity in your answer.  2.46e+11. What is the difference between the Value added (constant 2005 US$) in Brazil in 2007 and the Value added (constant 2005 US$) in Madagascar in 2008?
Your answer should be compact. 2.45e+11. What is the difference between the Value added (constant 2005 US$) in Dominica in 2007 and the Value added (constant 2005 US$) in Madagascar in 2008?
Give a very brief answer. -7.96e+08. What is the difference between the Value added (constant 2005 US$) in Afghanistan in 2007 and the Value added (constant 2005 US$) in Brazil in 2009?
Ensure brevity in your answer.  -2.51e+11. What is the difference between the Value added (constant 2005 US$) in Afghanistan in 2007 and the Value added (constant 2005 US$) in Dominica in 2009?
Provide a short and direct response. 1.98e+09. What is the difference between the Value added (constant 2005 US$) in Afghanistan in 2007 and the Value added (constant 2005 US$) in Madagascar in 2009?
Your answer should be very brief. 1.25e+09. What is the difference between the Value added (constant 2005 US$) of Brazil in 2007 and the Value added (constant 2005 US$) of Dominica in 2009?
Provide a short and direct response. 2.46e+11. What is the difference between the Value added (constant 2005 US$) of Brazil in 2007 and the Value added (constant 2005 US$) of Madagascar in 2009?
Your response must be concise. 2.45e+11. What is the difference between the Value added (constant 2005 US$) of Dominica in 2007 and the Value added (constant 2005 US$) of Madagascar in 2009?
Offer a terse response. -7.29e+08. What is the difference between the Value added (constant 2005 US$) in Afghanistan in 2008 and the Value added (constant 2005 US$) in Brazil in 2009?
Give a very brief answer. -2.51e+11. What is the difference between the Value added (constant 2005 US$) in Afghanistan in 2008 and the Value added (constant 2005 US$) in Dominica in 2009?
Your answer should be compact. 2.10e+09. What is the difference between the Value added (constant 2005 US$) of Afghanistan in 2008 and the Value added (constant 2005 US$) of Madagascar in 2009?
Provide a succinct answer. 1.37e+09. What is the difference between the Value added (constant 2005 US$) of Brazil in 2008 and the Value added (constant 2005 US$) of Dominica in 2009?
Provide a short and direct response. 2.59e+11. What is the difference between the Value added (constant 2005 US$) in Brazil in 2008 and the Value added (constant 2005 US$) in Madagascar in 2009?
Offer a very short reply. 2.59e+11. What is the difference between the Value added (constant 2005 US$) in Dominica in 2008 and the Value added (constant 2005 US$) in Madagascar in 2009?
Make the answer very short. -7.25e+08. What is the average Value added (constant 2005 US$) of Afghanistan per year?
Offer a very short reply. 1.74e+09. What is the average Value added (constant 2005 US$) of Brazil per year?
Provide a short and direct response. 2.25e+11. What is the average Value added (constant 2005 US$) in Dominica per year?
Your answer should be very brief. 4.86e+07. What is the average Value added (constant 2005 US$) in Madagascar per year?
Offer a very short reply. 7.32e+08. In the year 2002, what is the difference between the Value added (constant 2005 US$) of Afghanistan and Value added (constant 2005 US$) of Brazil?
Provide a succinct answer. -1.91e+11. In the year 2002, what is the difference between the Value added (constant 2005 US$) in Afghanistan and Value added (constant 2005 US$) in Dominica?
Keep it short and to the point. 1.10e+09. In the year 2002, what is the difference between the Value added (constant 2005 US$) of Afghanistan and Value added (constant 2005 US$) of Madagascar?
Your answer should be compact. 5.63e+08. In the year 2002, what is the difference between the Value added (constant 2005 US$) in Brazil and Value added (constant 2005 US$) in Dominica?
Offer a terse response. 1.92e+11. In the year 2002, what is the difference between the Value added (constant 2005 US$) of Brazil and Value added (constant 2005 US$) of Madagascar?
Ensure brevity in your answer.  1.92e+11. In the year 2002, what is the difference between the Value added (constant 2005 US$) in Dominica and Value added (constant 2005 US$) in Madagascar?
Offer a terse response. -5.37e+08. In the year 2003, what is the difference between the Value added (constant 2005 US$) in Afghanistan and Value added (constant 2005 US$) in Brazil?
Your answer should be compact. -1.92e+11. In the year 2003, what is the difference between the Value added (constant 2005 US$) in Afghanistan and Value added (constant 2005 US$) in Dominica?
Provide a succinct answer. 1.21e+09. In the year 2003, what is the difference between the Value added (constant 2005 US$) of Afghanistan and Value added (constant 2005 US$) of Madagascar?
Ensure brevity in your answer.  5.97e+08. In the year 2003, what is the difference between the Value added (constant 2005 US$) of Brazil and Value added (constant 2005 US$) of Dominica?
Ensure brevity in your answer.  1.93e+11. In the year 2003, what is the difference between the Value added (constant 2005 US$) in Brazil and Value added (constant 2005 US$) in Madagascar?
Provide a succinct answer. 1.92e+11. In the year 2003, what is the difference between the Value added (constant 2005 US$) in Dominica and Value added (constant 2005 US$) in Madagascar?
Keep it short and to the point. -6.16e+08. In the year 2004, what is the difference between the Value added (constant 2005 US$) of Afghanistan and Value added (constant 2005 US$) of Brazil?
Provide a succinct answer. -2.09e+11. In the year 2004, what is the difference between the Value added (constant 2005 US$) in Afghanistan and Value added (constant 2005 US$) in Dominica?
Keep it short and to the point. 1.43e+09. In the year 2004, what is the difference between the Value added (constant 2005 US$) of Afghanistan and Value added (constant 2005 US$) of Madagascar?
Offer a very short reply. 7.73e+08. In the year 2004, what is the difference between the Value added (constant 2005 US$) in Brazil and Value added (constant 2005 US$) in Dominica?
Provide a short and direct response. 2.11e+11. In the year 2004, what is the difference between the Value added (constant 2005 US$) in Brazil and Value added (constant 2005 US$) in Madagascar?
Make the answer very short. 2.10e+11. In the year 2004, what is the difference between the Value added (constant 2005 US$) of Dominica and Value added (constant 2005 US$) of Madagascar?
Provide a succinct answer. -6.55e+08. In the year 2005, what is the difference between the Value added (constant 2005 US$) of Afghanistan and Value added (constant 2005 US$) of Brazil?
Provide a short and direct response. -2.15e+11. In the year 2005, what is the difference between the Value added (constant 2005 US$) of Afghanistan and Value added (constant 2005 US$) of Dominica?
Keep it short and to the point. 1.62e+09. In the year 2005, what is the difference between the Value added (constant 2005 US$) in Afghanistan and Value added (constant 2005 US$) in Madagascar?
Ensure brevity in your answer.  9.43e+08. In the year 2005, what is the difference between the Value added (constant 2005 US$) in Brazil and Value added (constant 2005 US$) in Dominica?
Give a very brief answer. 2.17e+11. In the year 2005, what is the difference between the Value added (constant 2005 US$) in Brazil and Value added (constant 2005 US$) in Madagascar?
Ensure brevity in your answer.  2.16e+11. In the year 2005, what is the difference between the Value added (constant 2005 US$) in Dominica and Value added (constant 2005 US$) in Madagascar?
Make the answer very short. -6.74e+08. In the year 2006, what is the difference between the Value added (constant 2005 US$) of Afghanistan and Value added (constant 2005 US$) of Brazil?
Give a very brief answer. -2.26e+11. In the year 2006, what is the difference between the Value added (constant 2005 US$) in Afghanistan and Value added (constant 2005 US$) in Dominica?
Make the answer very short. 1.84e+09. In the year 2006, what is the difference between the Value added (constant 2005 US$) in Afghanistan and Value added (constant 2005 US$) in Madagascar?
Ensure brevity in your answer.  1.15e+09. In the year 2006, what is the difference between the Value added (constant 2005 US$) of Brazil and Value added (constant 2005 US$) of Dominica?
Give a very brief answer. 2.28e+11. In the year 2006, what is the difference between the Value added (constant 2005 US$) in Brazil and Value added (constant 2005 US$) in Madagascar?
Offer a terse response. 2.27e+11. In the year 2006, what is the difference between the Value added (constant 2005 US$) in Dominica and Value added (constant 2005 US$) in Madagascar?
Provide a short and direct response. -6.97e+08. In the year 2007, what is the difference between the Value added (constant 2005 US$) of Afghanistan and Value added (constant 2005 US$) of Brazil?
Provide a short and direct response. -2.44e+11. In the year 2007, what is the difference between the Value added (constant 2005 US$) in Afghanistan and Value added (constant 2005 US$) in Dominica?
Offer a terse response. 1.98e+09. In the year 2007, what is the difference between the Value added (constant 2005 US$) in Afghanistan and Value added (constant 2005 US$) in Madagascar?
Your answer should be compact. 1.22e+09. In the year 2007, what is the difference between the Value added (constant 2005 US$) in Brazil and Value added (constant 2005 US$) in Dominica?
Provide a succinct answer. 2.46e+11. In the year 2007, what is the difference between the Value added (constant 2005 US$) of Brazil and Value added (constant 2005 US$) of Madagascar?
Provide a succinct answer. 2.45e+11. In the year 2007, what is the difference between the Value added (constant 2005 US$) of Dominica and Value added (constant 2005 US$) of Madagascar?
Keep it short and to the point. -7.66e+08. In the year 2008, what is the difference between the Value added (constant 2005 US$) of Afghanistan and Value added (constant 2005 US$) of Brazil?
Provide a short and direct response. -2.57e+11. In the year 2008, what is the difference between the Value added (constant 2005 US$) of Afghanistan and Value added (constant 2005 US$) of Dominica?
Offer a terse response. 2.10e+09. In the year 2008, what is the difference between the Value added (constant 2005 US$) in Afghanistan and Value added (constant 2005 US$) in Madagascar?
Ensure brevity in your answer.  1.30e+09. In the year 2008, what is the difference between the Value added (constant 2005 US$) of Brazil and Value added (constant 2005 US$) of Dominica?
Provide a short and direct response. 2.59e+11. In the year 2008, what is the difference between the Value added (constant 2005 US$) of Brazil and Value added (constant 2005 US$) of Madagascar?
Your response must be concise. 2.59e+11. In the year 2008, what is the difference between the Value added (constant 2005 US$) in Dominica and Value added (constant 2005 US$) in Madagascar?
Your answer should be compact. -7.91e+08. In the year 2009, what is the difference between the Value added (constant 2005 US$) in Afghanistan and Value added (constant 2005 US$) in Brazil?
Keep it short and to the point. -2.51e+11. In the year 2009, what is the difference between the Value added (constant 2005 US$) of Afghanistan and Value added (constant 2005 US$) of Dominica?
Provide a succinct answer. 2.23e+09. In the year 2009, what is the difference between the Value added (constant 2005 US$) of Afghanistan and Value added (constant 2005 US$) of Madagascar?
Give a very brief answer. 1.50e+09. In the year 2009, what is the difference between the Value added (constant 2005 US$) in Brazil and Value added (constant 2005 US$) in Dominica?
Your answer should be very brief. 2.53e+11. In the year 2009, what is the difference between the Value added (constant 2005 US$) of Brazil and Value added (constant 2005 US$) of Madagascar?
Provide a short and direct response. 2.52e+11. In the year 2009, what is the difference between the Value added (constant 2005 US$) in Dominica and Value added (constant 2005 US$) in Madagascar?
Make the answer very short. -7.30e+08. What is the ratio of the Value added (constant 2005 US$) in Afghanistan in 2002 to that in 2003?
Make the answer very short. 0.91. What is the ratio of the Value added (constant 2005 US$) in Brazil in 2002 to that in 2003?
Provide a succinct answer. 1. What is the ratio of the Value added (constant 2005 US$) in Dominica in 2002 to that in 2003?
Your answer should be compact. 0.89. What is the ratio of the Value added (constant 2005 US$) of Madagascar in 2002 to that in 2003?
Your answer should be very brief. 0.87. What is the ratio of the Value added (constant 2005 US$) of Afghanistan in 2002 to that in 2004?
Ensure brevity in your answer.  0.77. What is the ratio of the Value added (constant 2005 US$) in Brazil in 2002 to that in 2004?
Provide a succinct answer. 0.91. What is the ratio of the Value added (constant 2005 US$) of Dominica in 2002 to that in 2004?
Provide a short and direct response. 0.82. What is the ratio of the Value added (constant 2005 US$) in Madagascar in 2002 to that in 2004?
Offer a very short reply. 0.82. What is the ratio of the Value added (constant 2005 US$) in Afghanistan in 2002 to that in 2005?
Make the answer very short. 0.68. What is the ratio of the Value added (constant 2005 US$) of Brazil in 2002 to that in 2005?
Your answer should be compact. 0.89. What is the ratio of the Value added (constant 2005 US$) of Dominica in 2002 to that in 2005?
Make the answer very short. 0.79. What is the ratio of the Value added (constant 2005 US$) of Madagascar in 2002 to that in 2005?
Your answer should be very brief. 0.8. What is the ratio of the Value added (constant 2005 US$) of Afghanistan in 2002 to that in 2006?
Your response must be concise. 0.6. What is the ratio of the Value added (constant 2005 US$) of Brazil in 2002 to that in 2006?
Provide a succinct answer. 0.85. What is the ratio of the Value added (constant 2005 US$) in Dominica in 2002 to that in 2006?
Your answer should be very brief. 0.75. What is the ratio of the Value added (constant 2005 US$) in Madagascar in 2002 to that in 2006?
Make the answer very short. 0.77. What is the ratio of the Value added (constant 2005 US$) in Afghanistan in 2002 to that in 2007?
Offer a terse response. 0.56. What is the ratio of the Value added (constant 2005 US$) of Brazil in 2002 to that in 2007?
Ensure brevity in your answer.  0.78. What is the ratio of the Value added (constant 2005 US$) of Dominica in 2002 to that in 2007?
Offer a terse response. 0.7. What is the ratio of the Value added (constant 2005 US$) in Madagascar in 2002 to that in 2007?
Make the answer very short. 0.7. What is the ratio of the Value added (constant 2005 US$) of Afghanistan in 2002 to that in 2008?
Your answer should be very brief. 0.53. What is the ratio of the Value added (constant 2005 US$) of Brazil in 2002 to that in 2008?
Keep it short and to the point. 0.74. What is the ratio of the Value added (constant 2005 US$) of Dominica in 2002 to that in 2008?
Ensure brevity in your answer.  0.65. What is the ratio of the Value added (constant 2005 US$) in Madagascar in 2002 to that in 2008?
Your answer should be very brief. 0.68. What is the ratio of the Value added (constant 2005 US$) in Afghanistan in 2002 to that in 2009?
Offer a very short reply. 0.5. What is the ratio of the Value added (constant 2005 US$) in Brazil in 2002 to that in 2009?
Offer a very short reply. 0.76. What is the ratio of the Value added (constant 2005 US$) of Dominica in 2002 to that in 2009?
Provide a succinct answer. 0.7. What is the ratio of the Value added (constant 2005 US$) in Madagascar in 2002 to that in 2009?
Provide a short and direct response. 0.73. What is the ratio of the Value added (constant 2005 US$) in Afghanistan in 2003 to that in 2004?
Your answer should be very brief. 0.85. What is the ratio of the Value added (constant 2005 US$) of Brazil in 2003 to that in 2004?
Provide a succinct answer. 0.92. What is the ratio of the Value added (constant 2005 US$) in Dominica in 2003 to that in 2004?
Make the answer very short. 0.91. What is the ratio of the Value added (constant 2005 US$) of Madagascar in 2003 to that in 2004?
Your response must be concise. 0.94. What is the ratio of the Value added (constant 2005 US$) in Afghanistan in 2003 to that in 2005?
Provide a succinct answer. 0.75. What is the ratio of the Value added (constant 2005 US$) of Brazil in 2003 to that in 2005?
Your answer should be very brief. 0.89. What is the ratio of the Value added (constant 2005 US$) of Dominica in 2003 to that in 2005?
Keep it short and to the point. 0.89. What is the ratio of the Value added (constant 2005 US$) in Madagascar in 2003 to that in 2005?
Your response must be concise. 0.91. What is the ratio of the Value added (constant 2005 US$) in Afghanistan in 2003 to that in 2006?
Your response must be concise. 0.66. What is the ratio of the Value added (constant 2005 US$) in Brazil in 2003 to that in 2006?
Make the answer very short. 0.85. What is the ratio of the Value added (constant 2005 US$) in Dominica in 2003 to that in 2006?
Your response must be concise. 0.84. What is the ratio of the Value added (constant 2005 US$) in Madagascar in 2003 to that in 2006?
Offer a very short reply. 0.88. What is the ratio of the Value added (constant 2005 US$) of Afghanistan in 2003 to that in 2007?
Give a very brief answer. 0.62. What is the ratio of the Value added (constant 2005 US$) in Brazil in 2003 to that in 2007?
Make the answer very short. 0.78. What is the ratio of the Value added (constant 2005 US$) of Dominica in 2003 to that in 2007?
Offer a terse response. 0.78. What is the ratio of the Value added (constant 2005 US$) in Madagascar in 2003 to that in 2007?
Provide a succinct answer. 0.8. What is the ratio of the Value added (constant 2005 US$) of Afghanistan in 2003 to that in 2008?
Offer a very short reply. 0.58. What is the ratio of the Value added (constant 2005 US$) in Brazil in 2003 to that in 2008?
Give a very brief answer. 0.74. What is the ratio of the Value added (constant 2005 US$) in Dominica in 2003 to that in 2008?
Make the answer very short. 0.72. What is the ratio of the Value added (constant 2005 US$) of Madagascar in 2003 to that in 2008?
Provide a short and direct response. 0.77. What is the ratio of the Value added (constant 2005 US$) in Afghanistan in 2003 to that in 2009?
Give a very brief answer. 0.55. What is the ratio of the Value added (constant 2005 US$) in Brazil in 2003 to that in 2009?
Make the answer very short. 0.76. What is the ratio of the Value added (constant 2005 US$) of Dominica in 2003 to that in 2009?
Keep it short and to the point. 0.79. What is the ratio of the Value added (constant 2005 US$) of Madagascar in 2003 to that in 2009?
Give a very brief answer. 0.84. What is the ratio of the Value added (constant 2005 US$) in Afghanistan in 2004 to that in 2005?
Give a very brief answer. 0.89. What is the ratio of the Value added (constant 2005 US$) in Brazil in 2004 to that in 2005?
Your answer should be compact. 0.97. What is the ratio of the Value added (constant 2005 US$) in Dominica in 2004 to that in 2005?
Give a very brief answer. 0.97. What is the ratio of the Value added (constant 2005 US$) of Madagascar in 2004 to that in 2005?
Keep it short and to the point. 0.97. What is the ratio of the Value added (constant 2005 US$) of Afghanistan in 2004 to that in 2006?
Give a very brief answer. 0.78. What is the ratio of the Value added (constant 2005 US$) in Brazil in 2004 to that in 2006?
Keep it short and to the point. 0.93. What is the ratio of the Value added (constant 2005 US$) of Dominica in 2004 to that in 2006?
Your answer should be compact. 0.92. What is the ratio of the Value added (constant 2005 US$) in Madagascar in 2004 to that in 2006?
Provide a short and direct response. 0.94. What is the ratio of the Value added (constant 2005 US$) in Afghanistan in 2004 to that in 2007?
Provide a succinct answer. 0.72. What is the ratio of the Value added (constant 2005 US$) in Brazil in 2004 to that in 2007?
Keep it short and to the point. 0.86. What is the ratio of the Value added (constant 2005 US$) of Dominica in 2004 to that in 2007?
Provide a short and direct response. 0.85. What is the ratio of the Value added (constant 2005 US$) of Madagascar in 2004 to that in 2007?
Your answer should be very brief. 0.85. What is the ratio of the Value added (constant 2005 US$) in Afghanistan in 2004 to that in 2008?
Provide a short and direct response. 0.68. What is the ratio of the Value added (constant 2005 US$) of Brazil in 2004 to that in 2008?
Offer a very short reply. 0.81. What is the ratio of the Value added (constant 2005 US$) in Dominica in 2004 to that in 2008?
Ensure brevity in your answer.  0.79. What is the ratio of the Value added (constant 2005 US$) of Madagascar in 2004 to that in 2008?
Give a very brief answer. 0.82. What is the ratio of the Value added (constant 2005 US$) in Afghanistan in 2004 to that in 2009?
Your answer should be compact. 0.64. What is the ratio of the Value added (constant 2005 US$) of Brazil in 2004 to that in 2009?
Offer a very short reply. 0.83. What is the ratio of the Value added (constant 2005 US$) in Dominica in 2004 to that in 2009?
Give a very brief answer. 0.86. What is the ratio of the Value added (constant 2005 US$) of Madagascar in 2004 to that in 2009?
Make the answer very short. 0.89. What is the ratio of the Value added (constant 2005 US$) in Afghanistan in 2005 to that in 2006?
Offer a very short reply. 0.88. What is the ratio of the Value added (constant 2005 US$) in Brazil in 2005 to that in 2006?
Your answer should be compact. 0.95. What is the ratio of the Value added (constant 2005 US$) of Dominica in 2005 to that in 2006?
Offer a terse response. 0.95. What is the ratio of the Value added (constant 2005 US$) of Madagascar in 2005 to that in 2006?
Offer a very short reply. 0.97. What is the ratio of the Value added (constant 2005 US$) of Afghanistan in 2005 to that in 2007?
Offer a terse response. 0.82. What is the ratio of the Value added (constant 2005 US$) of Brazil in 2005 to that in 2007?
Keep it short and to the point. 0.88. What is the ratio of the Value added (constant 2005 US$) in Dominica in 2005 to that in 2007?
Provide a short and direct response. 0.88. What is the ratio of the Value added (constant 2005 US$) of Madagascar in 2005 to that in 2007?
Offer a terse response. 0.88. What is the ratio of the Value added (constant 2005 US$) of Afghanistan in 2005 to that in 2008?
Make the answer very short. 0.77. What is the ratio of the Value added (constant 2005 US$) in Brazil in 2005 to that in 2008?
Offer a terse response. 0.84. What is the ratio of the Value added (constant 2005 US$) of Dominica in 2005 to that in 2008?
Provide a succinct answer. 0.81. What is the ratio of the Value added (constant 2005 US$) in Madagascar in 2005 to that in 2008?
Ensure brevity in your answer.  0.85. What is the ratio of the Value added (constant 2005 US$) of Afghanistan in 2005 to that in 2009?
Your answer should be very brief. 0.73. What is the ratio of the Value added (constant 2005 US$) of Brazil in 2005 to that in 2009?
Offer a very short reply. 0.86. What is the ratio of the Value added (constant 2005 US$) in Dominica in 2005 to that in 2009?
Offer a very short reply. 0.89. What is the ratio of the Value added (constant 2005 US$) of Madagascar in 2005 to that in 2009?
Provide a short and direct response. 0.92. What is the ratio of the Value added (constant 2005 US$) of Afghanistan in 2006 to that in 2007?
Make the answer very short. 0.93. What is the ratio of the Value added (constant 2005 US$) of Brazil in 2006 to that in 2007?
Provide a short and direct response. 0.92. What is the ratio of the Value added (constant 2005 US$) of Dominica in 2006 to that in 2007?
Offer a very short reply. 0.92. What is the ratio of the Value added (constant 2005 US$) in Madagascar in 2006 to that in 2007?
Provide a short and direct response. 0.91. What is the ratio of the Value added (constant 2005 US$) in Afghanistan in 2006 to that in 2008?
Your response must be concise. 0.88. What is the ratio of the Value added (constant 2005 US$) of Brazil in 2006 to that in 2008?
Your answer should be very brief. 0.88. What is the ratio of the Value added (constant 2005 US$) of Dominica in 2006 to that in 2008?
Provide a short and direct response. 0.86. What is the ratio of the Value added (constant 2005 US$) in Madagascar in 2006 to that in 2008?
Ensure brevity in your answer.  0.88. What is the ratio of the Value added (constant 2005 US$) in Afghanistan in 2006 to that in 2009?
Give a very brief answer. 0.83. What is the ratio of the Value added (constant 2005 US$) in Brazil in 2006 to that in 2009?
Ensure brevity in your answer.  0.9. What is the ratio of the Value added (constant 2005 US$) of Dominica in 2006 to that in 2009?
Give a very brief answer. 0.93. What is the ratio of the Value added (constant 2005 US$) in Madagascar in 2006 to that in 2009?
Ensure brevity in your answer.  0.95. What is the ratio of the Value added (constant 2005 US$) of Afghanistan in 2007 to that in 2008?
Make the answer very short. 0.95. What is the ratio of the Value added (constant 2005 US$) in Brazil in 2007 to that in 2008?
Offer a very short reply. 0.95. What is the ratio of the Value added (constant 2005 US$) in Dominica in 2007 to that in 2008?
Make the answer very short. 0.93. What is the ratio of the Value added (constant 2005 US$) in Madagascar in 2007 to that in 2008?
Give a very brief answer. 0.97. What is the ratio of the Value added (constant 2005 US$) in Afghanistan in 2007 to that in 2009?
Ensure brevity in your answer.  0.89. What is the ratio of the Value added (constant 2005 US$) in Brazil in 2007 to that in 2009?
Offer a terse response. 0.97. What is the ratio of the Value added (constant 2005 US$) in Dominica in 2007 to that in 2009?
Ensure brevity in your answer.  1.01. What is the ratio of the Value added (constant 2005 US$) of Madagascar in 2007 to that in 2009?
Offer a very short reply. 1.05. What is the ratio of the Value added (constant 2005 US$) in Afghanistan in 2008 to that in 2009?
Keep it short and to the point. 0.94. What is the ratio of the Value added (constant 2005 US$) of Brazil in 2008 to that in 2009?
Keep it short and to the point. 1.02. What is the ratio of the Value added (constant 2005 US$) in Dominica in 2008 to that in 2009?
Your answer should be compact. 1.09. What is the ratio of the Value added (constant 2005 US$) of Madagascar in 2008 to that in 2009?
Your answer should be very brief. 1.08. What is the difference between the highest and the second highest Value added (constant 2005 US$) of Afghanistan?
Provide a succinct answer. 1.32e+08. What is the difference between the highest and the second highest Value added (constant 2005 US$) in Brazil?
Provide a short and direct response. 6.24e+09. What is the difference between the highest and the second highest Value added (constant 2005 US$) in Dominica?
Provide a succinct answer. 4.34e+06. What is the difference between the highest and the second highest Value added (constant 2005 US$) in Madagascar?
Give a very brief answer. 2.93e+07. What is the difference between the highest and the lowest Value added (constant 2005 US$) in Afghanistan?
Ensure brevity in your answer.  1.15e+09. What is the difference between the highest and the lowest Value added (constant 2005 US$) in Brazil?
Give a very brief answer. 6.70e+1. What is the difference between the highest and the lowest Value added (constant 2005 US$) of Dominica?
Keep it short and to the point. 2.07e+07. What is the difference between the highest and the lowest Value added (constant 2005 US$) in Madagascar?
Offer a terse response. 2.75e+08. 